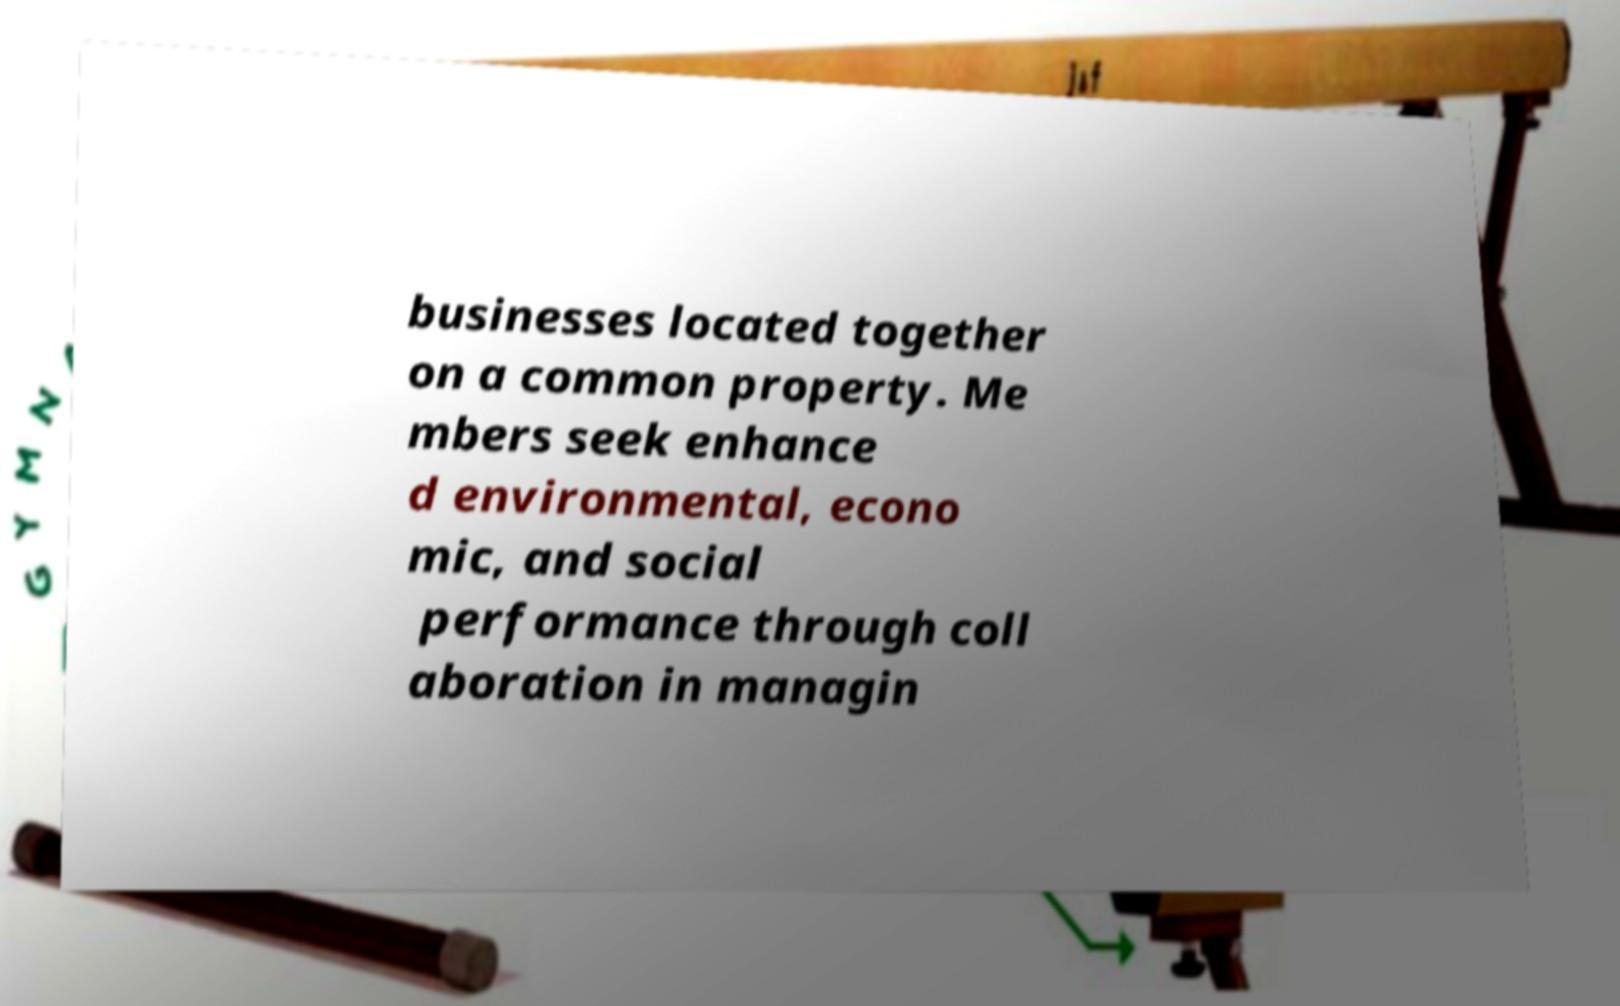Could you extract and type out the text from this image? businesses located together on a common property. Me mbers seek enhance d environmental, econo mic, and social performance through coll aboration in managin 